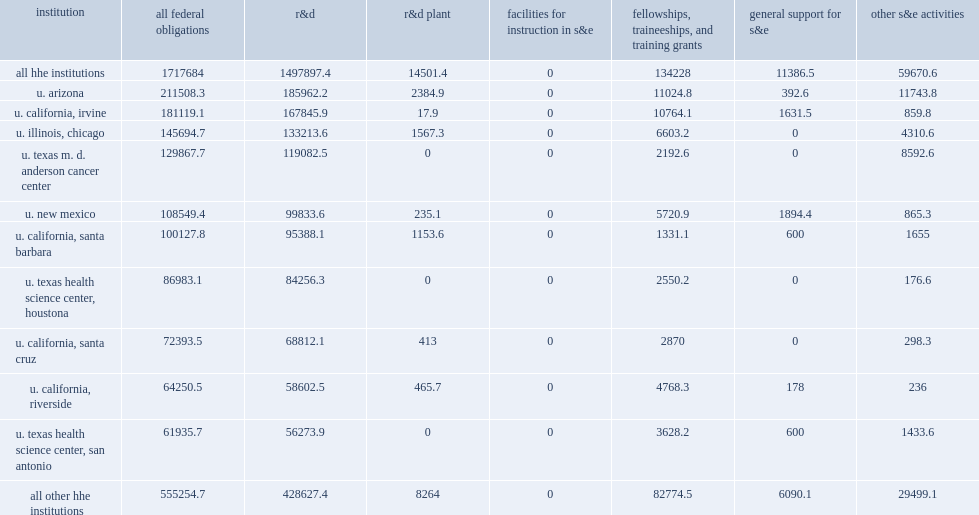Institutions in fy 2016, how many thousand dollars did hhe institutions receive in federal obligations for s&e? 1717684.0. Support for r&d accounted for $1.5 thousand, or 87% of the total s&e obligations. 1497897.4. How many percnet of the total s&e obligations did support for r&d account for? 0.872045. How many percent of federal s&e support did fttg accounted for? 0.078145. How many percent of federal s&e support did other s&e activities account for? 0.034739. 